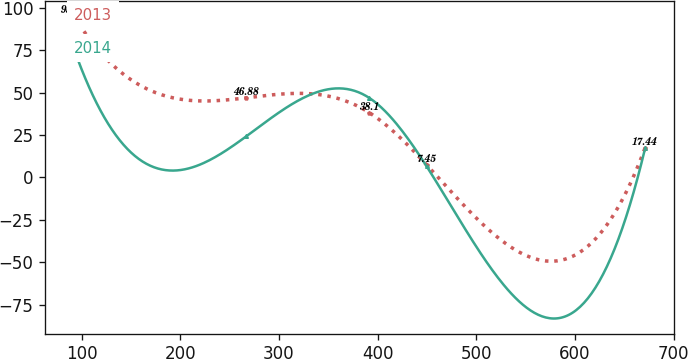<chart> <loc_0><loc_0><loc_500><loc_500><line_chart><ecel><fcel>2013<fcel>2014<nl><fcel>92.07<fcel>95.23<fcel>76.06<nl><fcel>266.78<fcel>46.88<fcel>24.13<nl><fcel>391.74<fcel>38.1<fcel>46.79<nl><fcel>449.65<fcel>7.45<fcel>6.58<nl><fcel>671.21<fcel>17.44<fcel>17.18<nl></chart> 